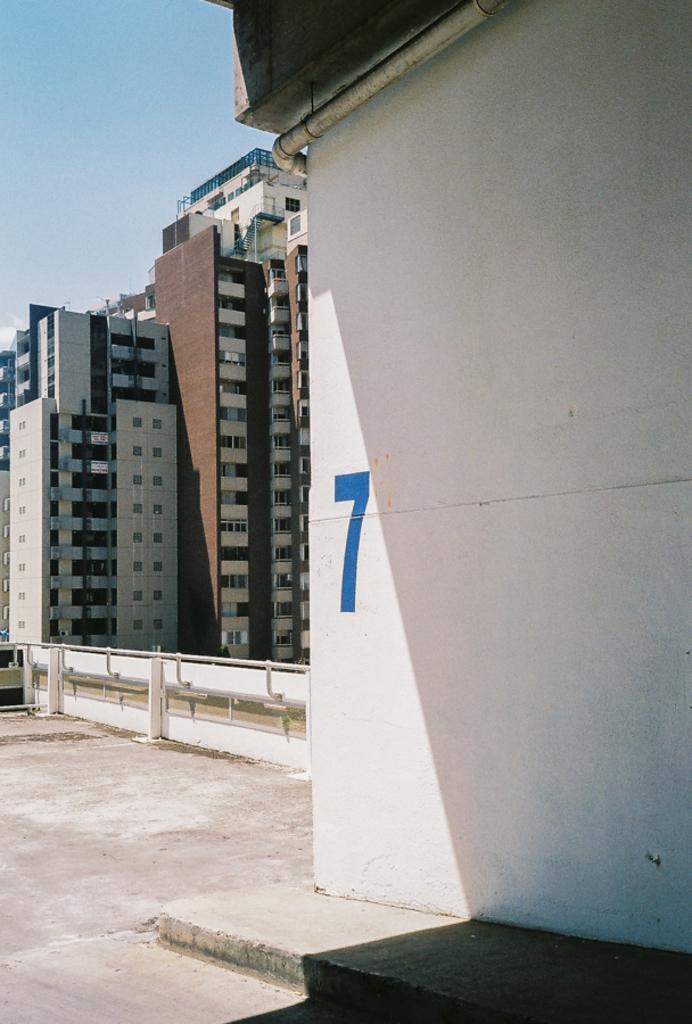Can you describe this image briefly? In this picture we can see some buildings. 